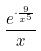Convert formula to latex. <formula><loc_0><loc_0><loc_500><loc_500>\frac { e ^ { \cdot \frac { 9 } { x ^ { 5 } } } } { x }</formula> 